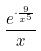Convert formula to latex. <formula><loc_0><loc_0><loc_500><loc_500>\frac { e ^ { \cdot \frac { 9 } { x ^ { 5 } } } } { x }</formula> 